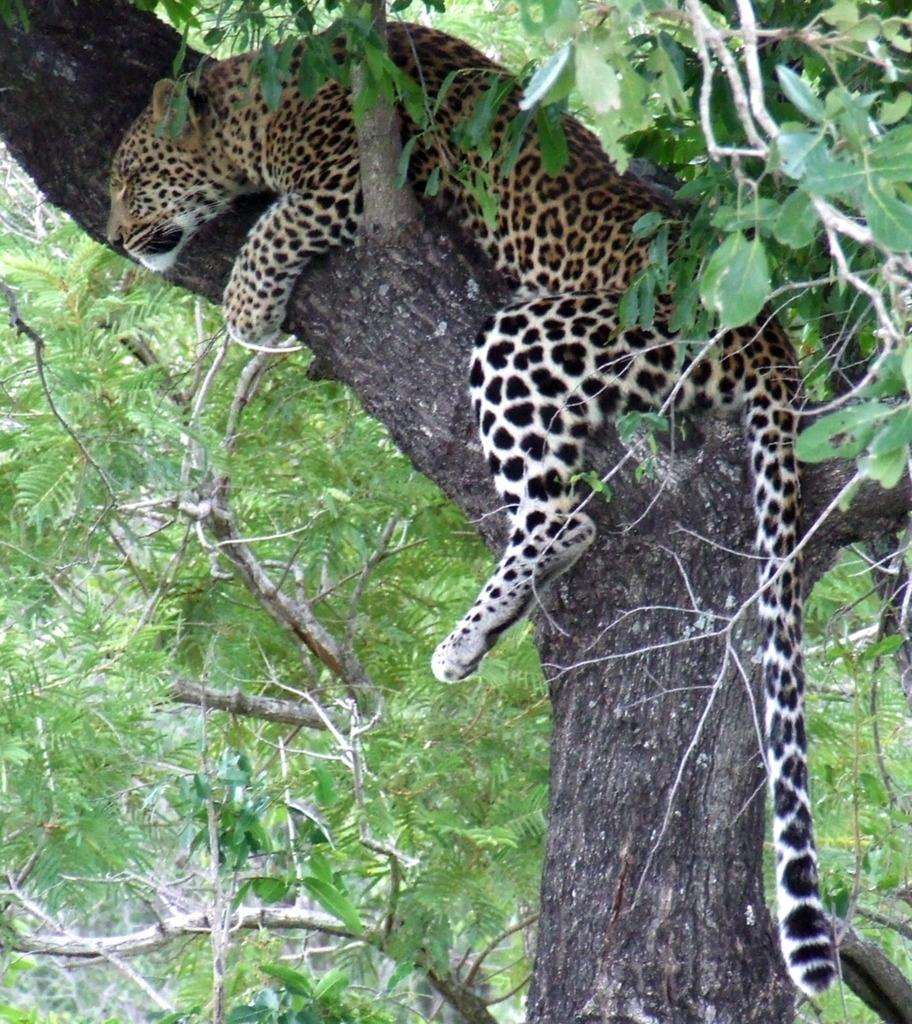What animal is the main subject of the image? There is a cheetah in the image. Where is the cheetah located in the image? The cheetah is on a tree. What can be seen in the background of the image? There are branches visible in the background of the image. What type of feast is being prepared in the alley in the image? There is no alley or feast present in the image; it features a cheetah on a tree with branches in the background. 